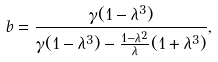<formula> <loc_0><loc_0><loc_500><loc_500>b = \frac { \gamma ( 1 - \lambda ^ { 3 } ) } { \gamma ( 1 - \lambda ^ { 3 } ) - \frac { 1 - \lambda ^ { 2 } } { \lambda } ( 1 + \lambda ^ { 3 } ) } ,</formula> 